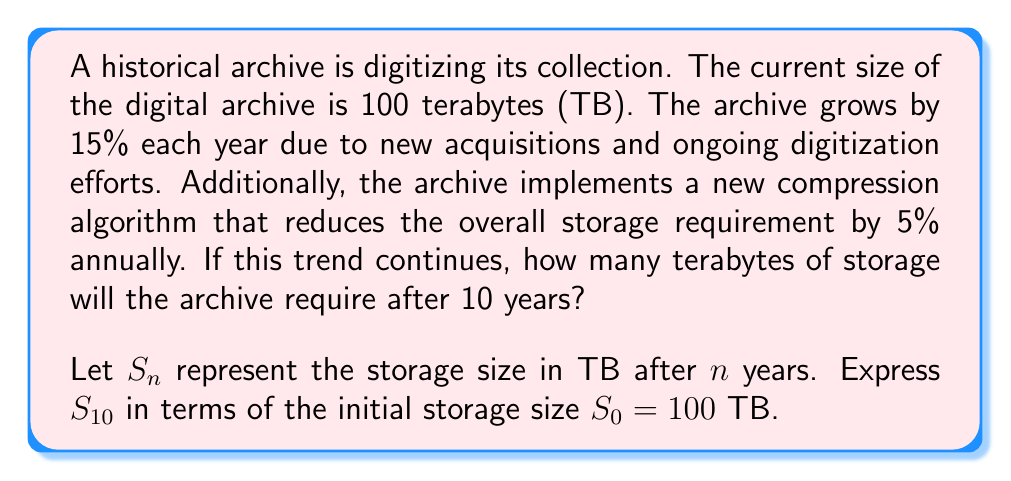Solve this math problem. To solve this problem, we need to consider both the growth and reduction factors for each year:

1. Growth factor due to new acquisitions: 1.15 (15% increase)
2. Reduction factor due to compression: 0.95 (5% decrease)

The combined factor for each year is: $1.15 \times 0.95 = 1.0925$

We can express this as a geometric sequence:

$$S_n = S_0 \times (1.0925)^n$$

Where:
$S_n$ is the storage size after $n$ years
$S_0$ is the initial storage size (100 TB)
$n$ is the number of years (10 in this case)

Substituting the values:

$$S_{10} = 100 \times (1.0925)^{10}$$

Using a calculator or computer:

$$S_{10} = 100 \times 2.4132...$$

$$S_{10} = 241.32... \text{ TB}$$

Rounding to two decimal places:

$$S_{10} \approx 241.32 \text{ TB}$$
Answer: After 10 years, the archive will require approximately 241.32 TB of storage. 